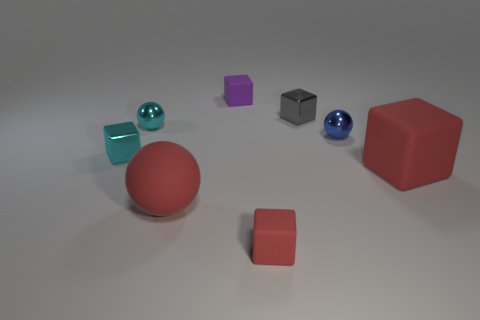What number of objects are small gray cubes or small matte blocks that are behind the gray thing?
Offer a terse response. 2. Does the gray object have the same material as the small blue object?
Keep it short and to the point. Yes. How many other objects are the same material as the big sphere?
Offer a terse response. 3. Are there more big purple matte blocks than gray shiny objects?
Offer a very short reply. No. There is a tiny metallic object to the left of the cyan ball; is its shape the same as the blue metallic thing?
Make the answer very short. No. Is the number of small gray cubes less than the number of large things?
Offer a very short reply. Yes. There is a gray block that is the same size as the blue metallic sphere; what material is it?
Your answer should be compact. Metal. There is a large matte ball; is its color the same as the ball that is behind the blue metal thing?
Offer a very short reply. No. Are there fewer tiny balls that are to the left of the tiny blue ball than purple matte cylinders?
Your answer should be compact. No. How many purple rubber blocks are there?
Provide a succinct answer. 1. 